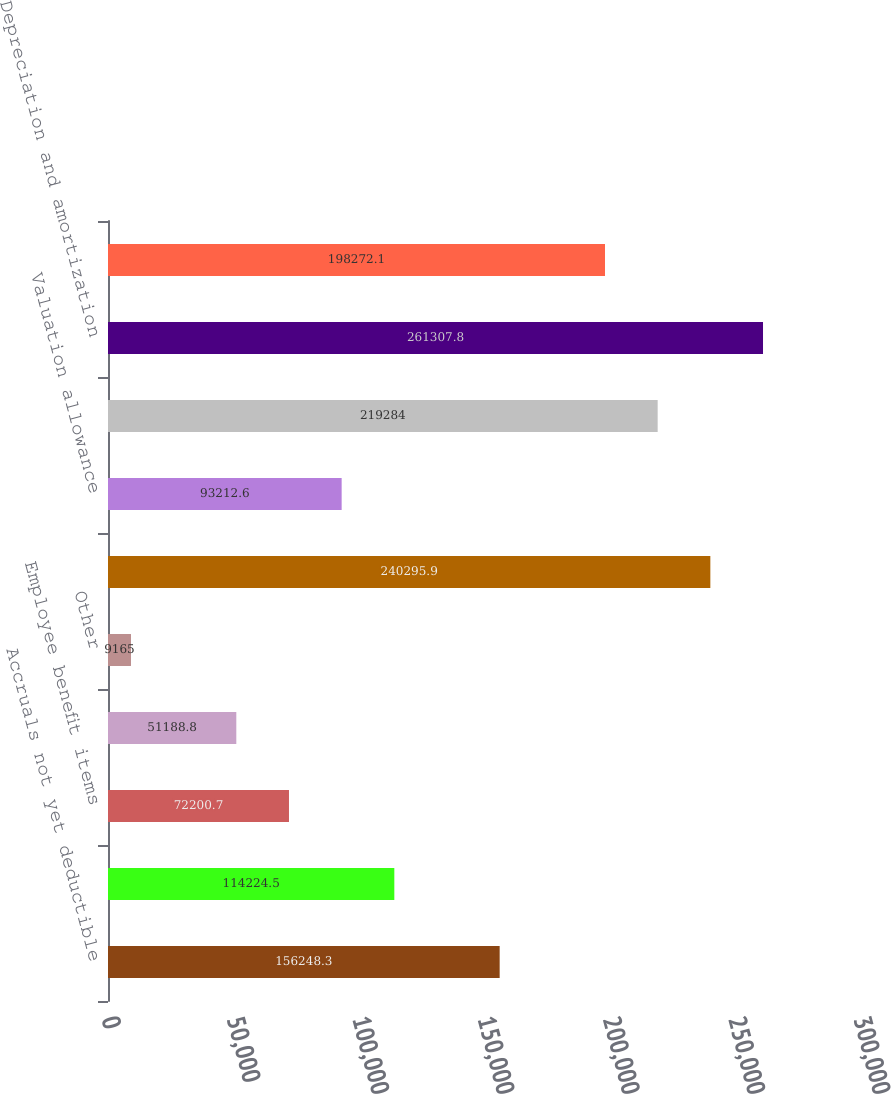Convert chart. <chart><loc_0><loc_0><loc_500><loc_500><bar_chart><fcel>Accruals not yet deductible<fcel>Foreign net operating loss<fcel>Employee benefit items<fcel>Inventories<fcel>Other<fcel>Gross deferred tax assets<fcel>Valuation allowance<fcel>Total deferred tax assets<fcel>Depreciation and amortization<fcel>Unremitted foreign earnings<nl><fcel>156248<fcel>114224<fcel>72200.7<fcel>51188.8<fcel>9165<fcel>240296<fcel>93212.6<fcel>219284<fcel>261308<fcel>198272<nl></chart> 